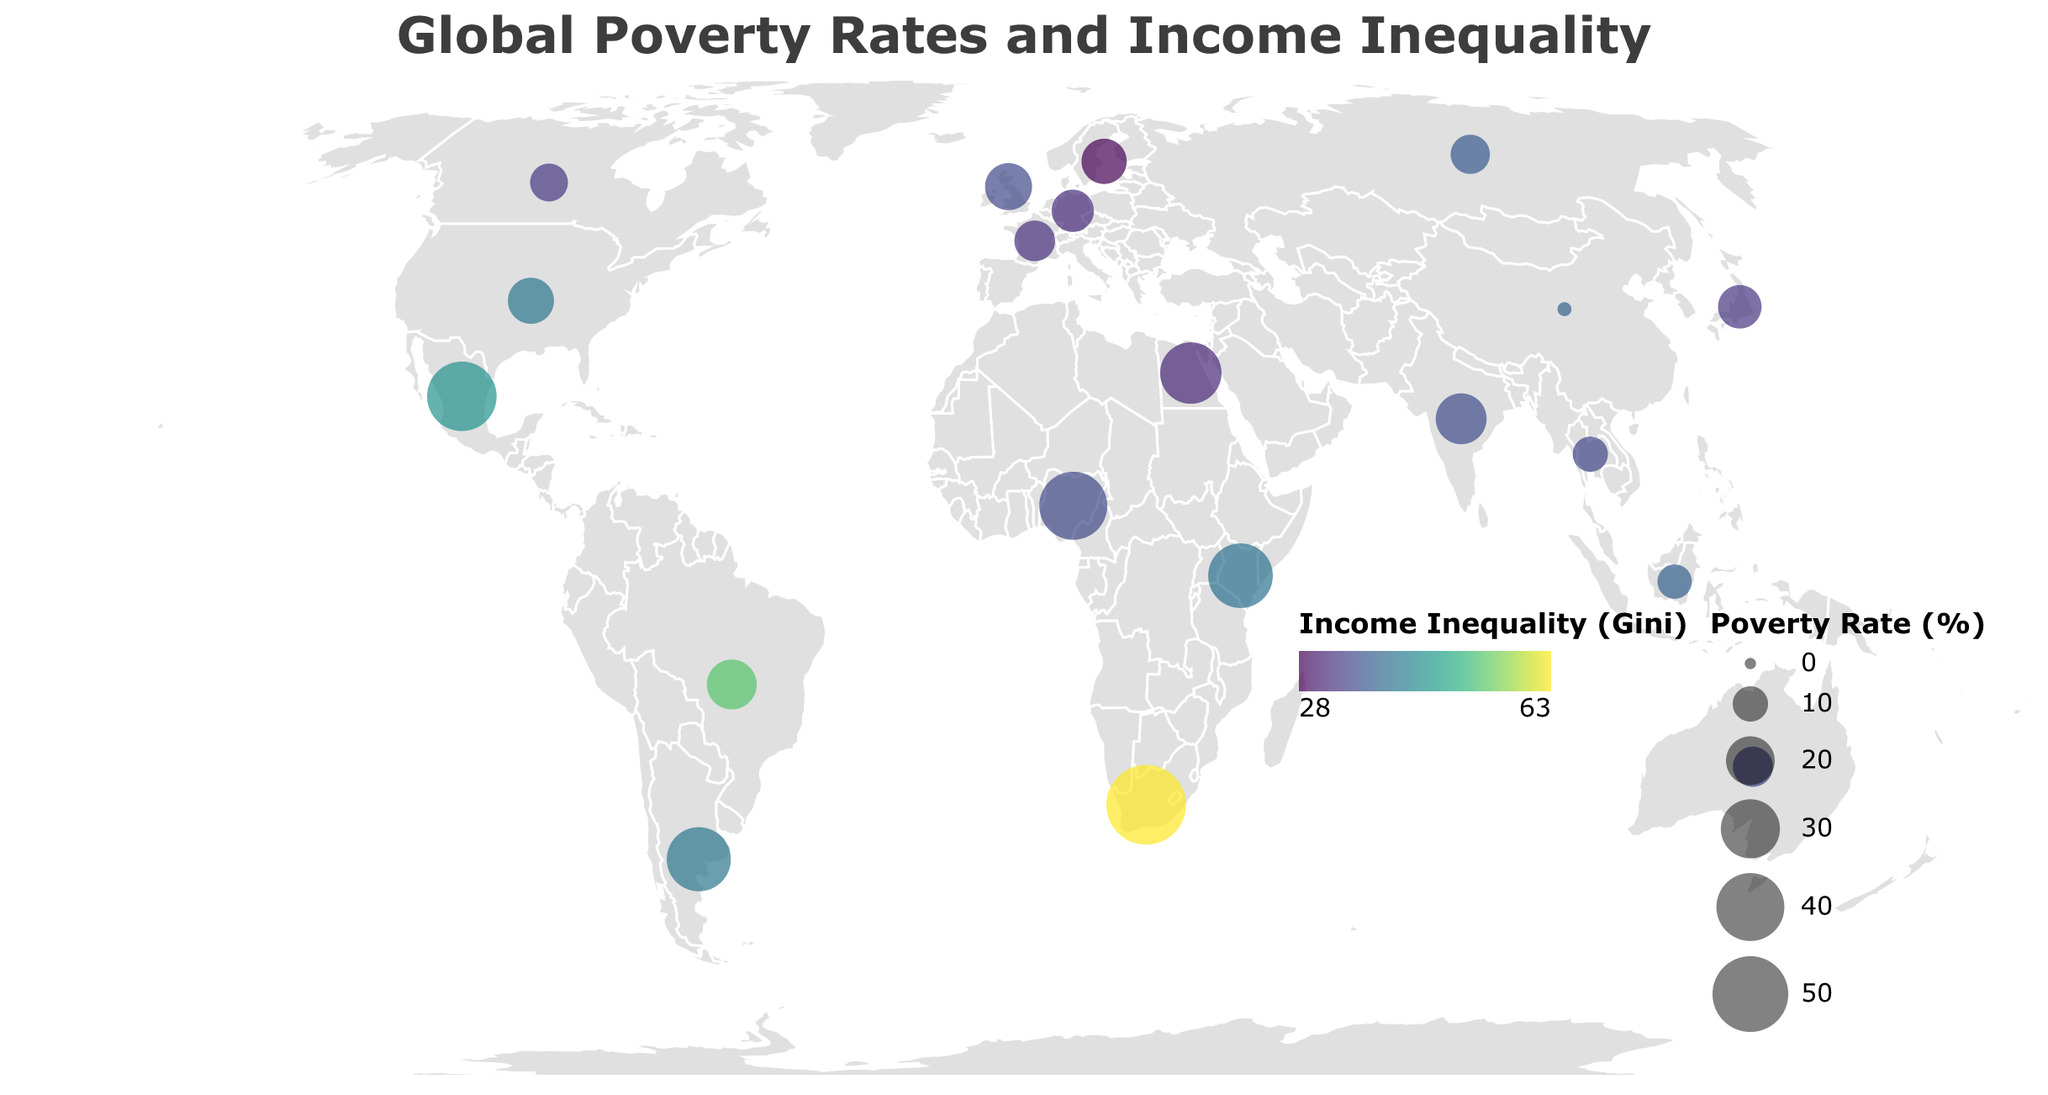How many countries have a poverty rate above 20%? To find the number of countries with a poverty rate above 20%, look at the size of the circles; larger circles indicate higher poverty rates. Check the tooltip for each country's poverty rate and count those above 20%.
Answer: 9 Which country has the highest income inequality (Gini index)? Compare the Gini index values shown in the tooltips of each country. Identify the highest value.
Answer: South Africa Which country has the lowest poverty rate and what is its income inequality (Gini index)? Find the country with the smallest circle (lowest poverty rate), and check its tooltip for the corresponding Gini index value.
Answer: China, 38.5 Which countries have both high poverty rates (above 30%) and high income inequality (Gini index above 40)? Focus on the large circles (high poverty rates) and further verify the income inequality value in the tooltip to see if it exceeds 40. Count and list these countries.
Answer: South Africa, Mexico, Argentina How does the poverty rate in France compare to that in Germany? Look at the size of the circles for France and Germany, check their tooltips for precise poverty rates, and compare these values.
Answer: France (13.6%) has a slightly lower poverty rate than Germany (14.8%) Which countries are colored with the most contrasting colors, indicating vastly different income inequality levels? Notice the color gradient representing income inequality. Identify countries with significantly different colors and confirm with the tooltip values.
Answer: Sweden (low inequality) and South Africa (high inequality) What is the average poverty rate of the countries listed in the plot? Add up the poverty rates of all countries and divide by the number of countries. (17.8+21.0+21.9+55.5+14.8+0.6+40.1+17.1+41.9+15.7+12.6+36.1+13.6+13.2+9.4+11.6+35.5+32.5+18.6+9.9) ÷ 20.
Answer: 22.6% Which region (latitude and longitude) has the largest circle, indicating the highest poverty rate? Look for the largest circle on the map and check its corresponding tooltip to determine its latitude and longitude.
Answer: South Africa (-30.5595, 22.9375) Between the United States and Canada, which country has a higher income inequality (Gini index), and by how much? Check the tooltips for the United States and Canada's Gini index values, subtract the smaller value from the larger to find the difference.
Answer: United States is higher by 8.2 (41.5 - 33.3 = 8.2) How many countries have both a poverty rate below 20% and a Gini index below 35? Identify countries with small circles (low poverty rate) and verify from the tooltip if their Gini index is also below 35. Count these countries.
Answer: 3 